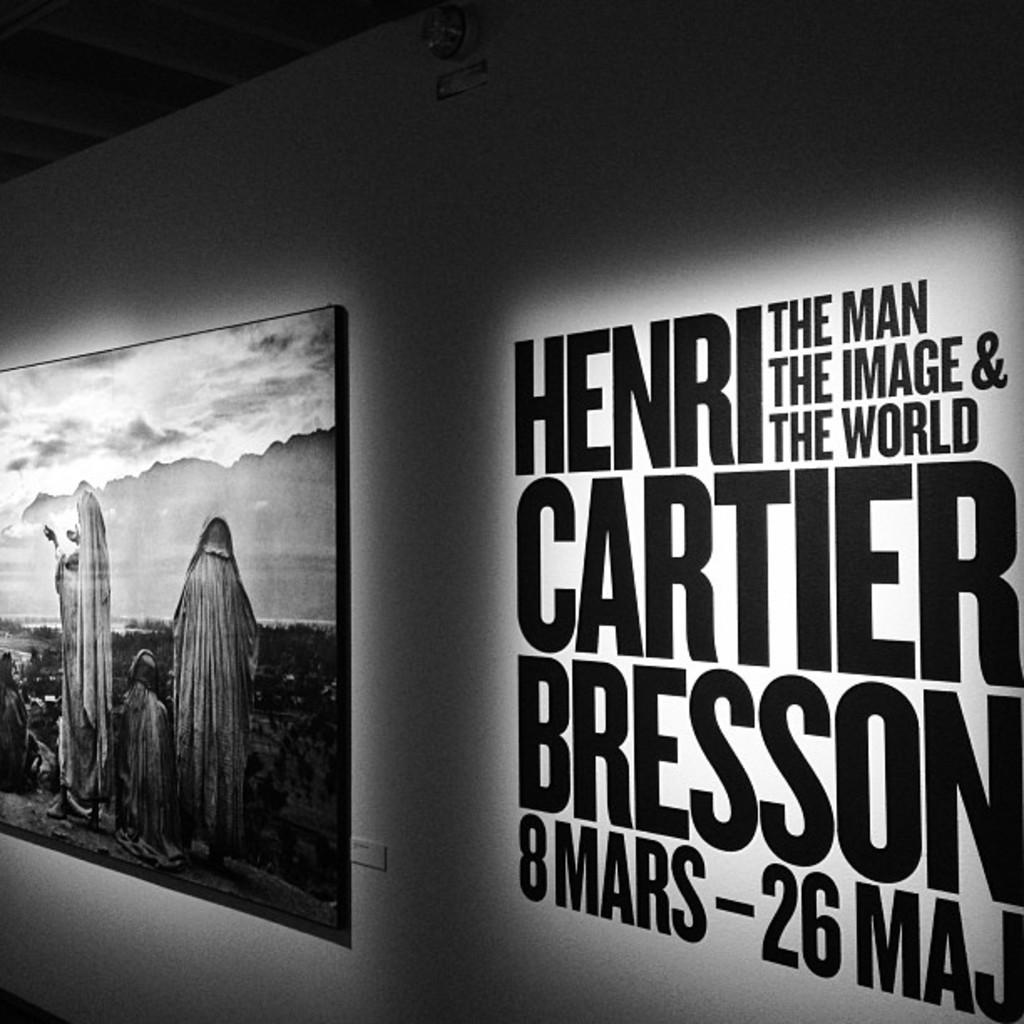<image>
Offer a succinct explanation of the picture presented. Vinyl on a wall advertises an event for Henri Cartier Bresson. 